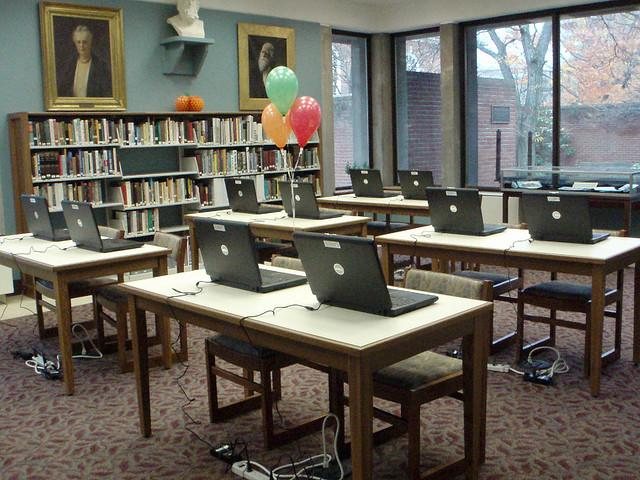What setting is this picture taken in? Please explain your reasoning. computer lab. A classroom with lap tops in it. 